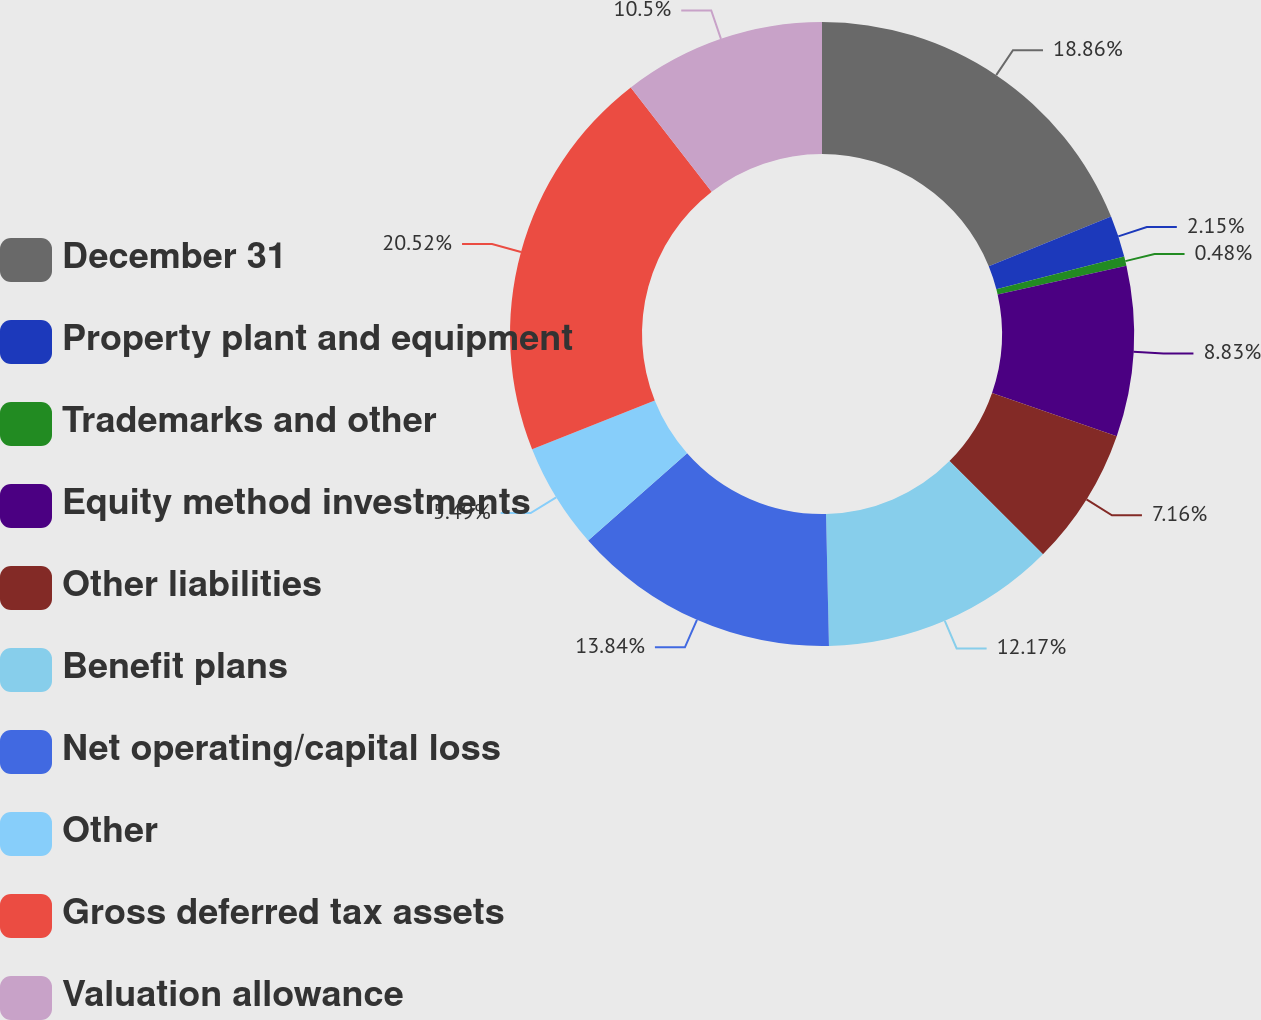Convert chart. <chart><loc_0><loc_0><loc_500><loc_500><pie_chart><fcel>December 31<fcel>Property plant and equipment<fcel>Trademarks and other<fcel>Equity method investments<fcel>Other liabilities<fcel>Benefit plans<fcel>Net operating/capital loss<fcel>Other<fcel>Gross deferred tax assets<fcel>Valuation allowance<nl><fcel>18.86%<fcel>2.15%<fcel>0.48%<fcel>8.83%<fcel>7.16%<fcel>12.17%<fcel>13.84%<fcel>5.49%<fcel>20.53%<fcel>10.5%<nl></chart> 